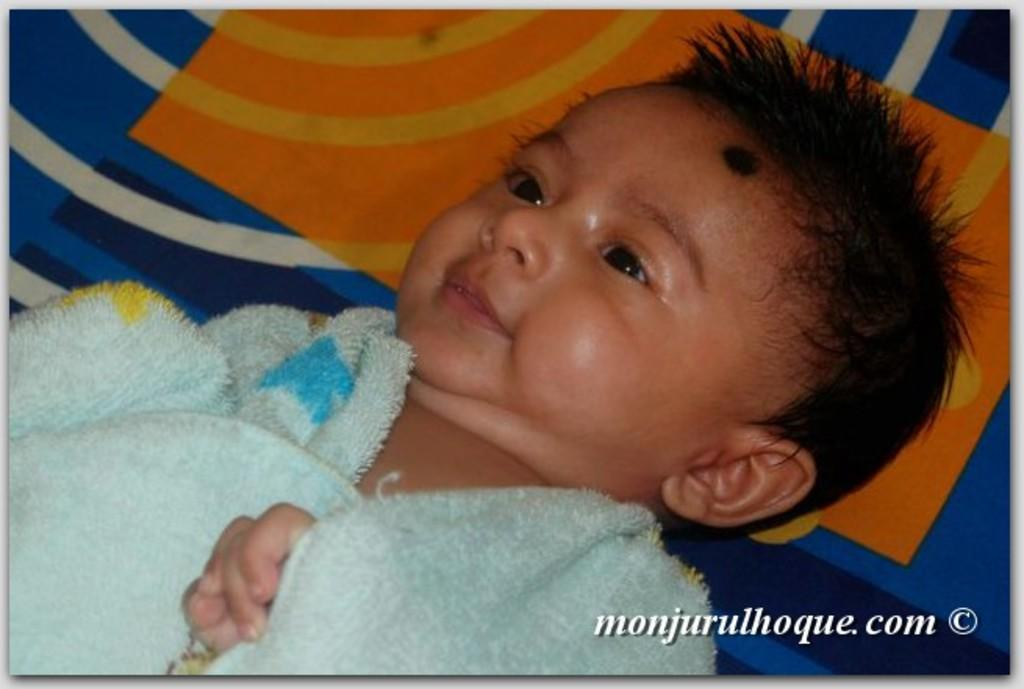What is the main subject of the image? There is a baby in the image. What is the baby's position in the image? The baby is laying down. Is there any text present in the image? Yes, there is text visible at the bottom of the image. What might the baby be laying on? The baby might be laying on a bed. How many toes can be seen on the baby's cast in the image? There is no cast visible in the image, and therefore no toes can be seen on a cast. 